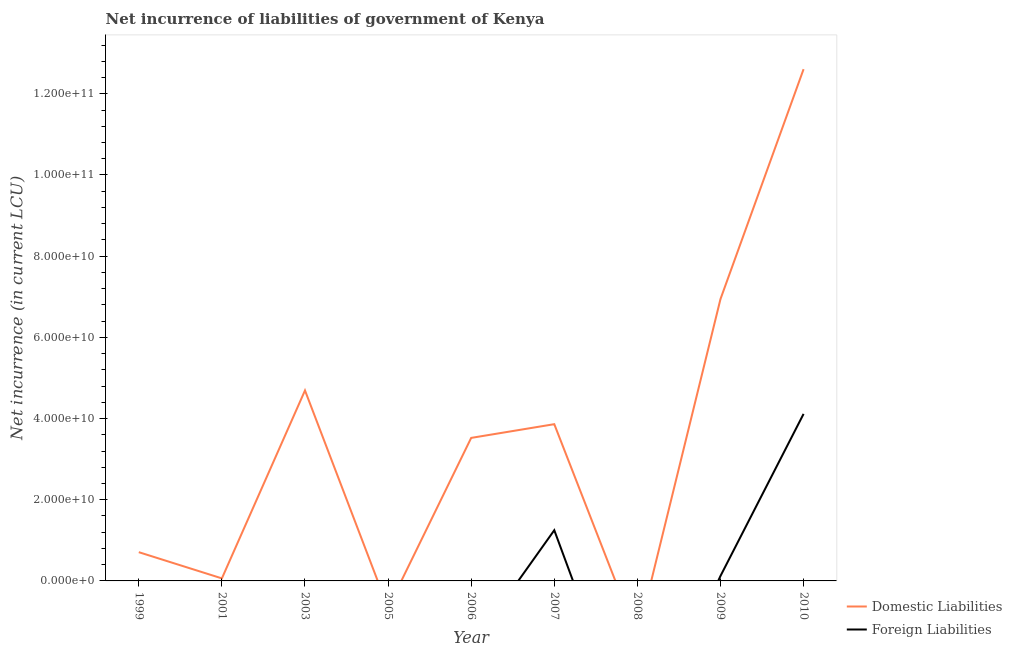What is the net incurrence of domestic liabilities in 1999?
Your response must be concise. 7.08e+09. Across all years, what is the maximum net incurrence of domestic liabilities?
Ensure brevity in your answer.  1.26e+11. Across all years, what is the minimum net incurrence of foreign liabilities?
Offer a very short reply. 0. What is the total net incurrence of domestic liabilities in the graph?
Your answer should be compact. 3.24e+11. What is the difference between the net incurrence of domestic liabilities in 1999 and that in 2001?
Provide a succinct answer. 6.46e+09. What is the average net incurrence of domestic liabilities per year?
Offer a terse response. 3.60e+1. In the year 2009, what is the difference between the net incurrence of foreign liabilities and net incurrence of domestic liabilities?
Provide a succinct answer. -6.82e+1. In how many years, is the net incurrence of foreign liabilities greater than 104000000000 LCU?
Provide a short and direct response. 0. What is the ratio of the net incurrence of domestic liabilities in 1999 to that in 2006?
Provide a succinct answer. 0.2. Is the net incurrence of domestic liabilities in 1999 less than that in 2003?
Your answer should be very brief. Yes. What is the difference between the highest and the second highest net incurrence of foreign liabilities?
Provide a succinct answer. 2.87e+1. What is the difference between the highest and the lowest net incurrence of foreign liabilities?
Ensure brevity in your answer.  4.11e+1. Is the sum of the net incurrence of foreign liabilities in 2007 and 2009 greater than the maximum net incurrence of domestic liabilities across all years?
Your response must be concise. No. Is the net incurrence of foreign liabilities strictly greater than the net incurrence of domestic liabilities over the years?
Provide a succinct answer. No. Is the net incurrence of domestic liabilities strictly less than the net incurrence of foreign liabilities over the years?
Your answer should be compact. No. How many lines are there?
Offer a very short reply. 2. How many years are there in the graph?
Give a very brief answer. 9. Are the values on the major ticks of Y-axis written in scientific E-notation?
Your answer should be compact. Yes. Does the graph contain grids?
Provide a short and direct response. No. Where does the legend appear in the graph?
Your answer should be compact. Bottom right. What is the title of the graph?
Provide a succinct answer. Net incurrence of liabilities of government of Kenya. What is the label or title of the X-axis?
Provide a succinct answer. Year. What is the label or title of the Y-axis?
Offer a terse response. Net incurrence (in current LCU). What is the Net incurrence (in current LCU) of Domestic Liabilities in 1999?
Keep it short and to the point. 7.08e+09. What is the Net incurrence (in current LCU) in Domestic Liabilities in 2001?
Provide a succinct answer. 6.24e+08. What is the Net incurrence (in current LCU) in Domestic Liabilities in 2003?
Provide a succinct answer. 4.69e+1. What is the Net incurrence (in current LCU) in Domestic Liabilities in 2006?
Offer a terse response. 3.52e+1. What is the Net incurrence (in current LCU) of Foreign Liabilities in 2006?
Ensure brevity in your answer.  0. What is the Net incurrence (in current LCU) of Domestic Liabilities in 2007?
Offer a very short reply. 3.86e+1. What is the Net incurrence (in current LCU) in Foreign Liabilities in 2007?
Provide a succinct answer. 1.25e+1. What is the Net incurrence (in current LCU) in Domestic Liabilities in 2008?
Offer a very short reply. 0. What is the Net incurrence (in current LCU) in Foreign Liabilities in 2008?
Give a very brief answer. 0. What is the Net incurrence (in current LCU) of Domestic Liabilities in 2009?
Provide a succinct answer. 6.94e+1. What is the Net incurrence (in current LCU) of Foreign Liabilities in 2009?
Your answer should be very brief. 1.22e+09. What is the Net incurrence (in current LCU) in Domestic Liabilities in 2010?
Give a very brief answer. 1.26e+11. What is the Net incurrence (in current LCU) of Foreign Liabilities in 2010?
Your answer should be very brief. 4.11e+1. Across all years, what is the maximum Net incurrence (in current LCU) in Domestic Liabilities?
Offer a very short reply. 1.26e+11. Across all years, what is the maximum Net incurrence (in current LCU) of Foreign Liabilities?
Your answer should be compact. 4.11e+1. Across all years, what is the minimum Net incurrence (in current LCU) of Domestic Liabilities?
Give a very brief answer. 0. Across all years, what is the minimum Net incurrence (in current LCU) in Foreign Liabilities?
Your answer should be compact. 0. What is the total Net incurrence (in current LCU) of Domestic Liabilities in the graph?
Your answer should be compact. 3.24e+11. What is the total Net incurrence (in current LCU) of Foreign Liabilities in the graph?
Offer a very short reply. 5.48e+1. What is the difference between the Net incurrence (in current LCU) of Domestic Liabilities in 1999 and that in 2001?
Ensure brevity in your answer.  6.46e+09. What is the difference between the Net incurrence (in current LCU) of Domestic Liabilities in 1999 and that in 2003?
Give a very brief answer. -3.98e+1. What is the difference between the Net incurrence (in current LCU) of Domestic Liabilities in 1999 and that in 2006?
Offer a terse response. -2.81e+1. What is the difference between the Net incurrence (in current LCU) in Domestic Liabilities in 1999 and that in 2007?
Ensure brevity in your answer.  -3.15e+1. What is the difference between the Net incurrence (in current LCU) in Domestic Liabilities in 1999 and that in 2009?
Your answer should be compact. -6.23e+1. What is the difference between the Net incurrence (in current LCU) in Domestic Liabilities in 1999 and that in 2010?
Provide a short and direct response. -1.19e+11. What is the difference between the Net incurrence (in current LCU) of Domestic Liabilities in 2001 and that in 2003?
Provide a succinct answer. -4.63e+1. What is the difference between the Net incurrence (in current LCU) of Domestic Liabilities in 2001 and that in 2006?
Offer a very short reply. -3.46e+1. What is the difference between the Net incurrence (in current LCU) in Domestic Liabilities in 2001 and that in 2007?
Provide a short and direct response. -3.80e+1. What is the difference between the Net incurrence (in current LCU) in Domestic Liabilities in 2001 and that in 2009?
Your response must be concise. -6.88e+1. What is the difference between the Net incurrence (in current LCU) in Domestic Liabilities in 2001 and that in 2010?
Offer a very short reply. -1.25e+11. What is the difference between the Net incurrence (in current LCU) of Domestic Liabilities in 2003 and that in 2006?
Provide a short and direct response. 1.17e+1. What is the difference between the Net incurrence (in current LCU) in Domestic Liabilities in 2003 and that in 2007?
Your answer should be compact. 8.31e+09. What is the difference between the Net incurrence (in current LCU) in Domestic Liabilities in 2003 and that in 2009?
Ensure brevity in your answer.  -2.25e+1. What is the difference between the Net incurrence (in current LCU) of Domestic Liabilities in 2003 and that in 2010?
Your answer should be very brief. -7.91e+1. What is the difference between the Net incurrence (in current LCU) of Domestic Liabilities in 2006 and that in 2007?
Your answer should be compact. -3.38e+09. What is the difference between the Net incurrence (in current LCU) in Domestic Liabilities in 2006 and that in 2009?
Ensure brevity in your answer.  -3.42e+1. What is the difference between the Net incurrence (in current LCU) of Domestic Liabilities in 2006 and that in 2010?
Your answer should be compact. -9.08e+1. What is the difference between the Net incurrence (in current LCU) of Domestic Liabilities in 2007 and that in 2009?
Ensure brevity in your answer.  -3.08e+1. What is the difference between the Net incurrence (in current LCU) of Foreign Liabilities in 2007 and that in 2009?
Your response must be concise. 1.13e+1. What is the difference between the Net incurrence (in current LCU) in Domestic Liabilities in 2007 and that in 2010?
Your answer should be compact. -8.74e+1. What is the difference between the Net incurrence (in current LCU) in Foreign Liabilities in 2007 and that in 2010?
Your answer should be very brief. -2.87e+1. What is the difference between the Net incurrence (in current LCU) in Domestic Liabilities in 2009 and that in 2010?
Your response must be concise. -5.66e+1. What is the difference between the Net incurrence (in current LCU) of Foreign Liabilities in 2009 and that in 2010?
Ensure brevity in your answer.  -3.99e+1. What is the difference between the Net incurrence (in current LCU) in Domestic Liabilities in 1999 and the Net incurrence (in current LCU) in Foreign Liabilities in 2007?
Your response must be concise. -5.41e+09. What is the difference between the Net incurrence (in current LCU) in Domestic Liabilities in 1999 and the Net incurrence (in current LCU) in Foreign Liabilities in 2009?
Make the answer very short. 5.87e+09. What is the difference between the Net incurrence (in current LCU) of Domestic Liabilities in 1999 and the Net incurrence (in current LCU) of Foreign Liabilities in 2010?
Offer a terse response. -3.41e+1. What is the difference between the Net incurrence (in current LCU) in Domestic Liabilities in 2001 and the Net incurrence (in current LCU) in Foreign Liabilities in 2007?
Give a very brief answer. -1.19e+1. What is the difference between the Net incurrence (in current LCU) of Domestic Liabilities in 2001 and the Net incurrence (in current LCU) of Foreign Liabilities in 2009?
Keep it short and to the point. -5.92e+08. What is the difference between the Net incurrence (in current LCU) of Domestic Liabilities in 2001 and the Net incurrence (in current LCU) of Foreign Liabilities in 2010?
Provide a succinct answer. -4.05e+1. What is the difference between the Net incurrence (in current LCU) of Domestic Liabilities in 2003 and the Net incurrence (in current LCU) of Foreign Liabilities in 2007?
Keep it short and to the point. 3.44e+1. What is the difference between the Net incurrence (in current LCU) in Domestic Liabilities in 2003 and the Net incurrence (in current LCU) in Foreign Liabilities in 2009?
Offer a very short reply. 4.57e+1. What is the difference between the Net incurrence (in current LCU) in Domestic Liabilities in 2003 and the Net incurrence (in current LCU) in Foreign Liabilities in 2010?
Your response must be concise. 5.78e+09. What is the difference between the Net incurrence (in current LCU) in Domestic Liabilities in 2006 and the Net incurrence (in current LCU) in Foreign Liabilities in 2007?
Your response must be concise. 2.27e+1. What is the difference between the Net incurrence (in current LCU) of Domestic Liabilities in 2006 and the Net incurrence (in current LCU) of Foreign Liabilities in 2009?
Your answer should be very brief. 3.40e+1. What is the difference between the Net incurrence (in current LCU) in Domestic Liabilities in 2006 and the Net incurrence (in current LCU) in Foreign Liabilities in 2010?
Make the answer very short. -5.91e+09. What is the difference between the Net incurrence (in current LCU) of Domestic Liabilities in 2007 and the Net incurrence (in current LCU) of Foreign Liabilities in 2009?
Your answer should be very brief. 3.74e+1. What is the difference between the Net incurrence (in current LCU) in Domestic Liabilities in 2007 and the Net incurrence (in current LCU) in Foreign Liabilities in 2010?
Offer a terse response. -2.53e+09. What is the difference between the Net incurrence (in current LCU) in Domestic Liabilities in 2009 and the Net incurrence (in current LCU) in Foreign Liabilities in 2010?
Your answer should be very brief. 2.83e+1. What is the average Net incurrence (in current LCU) in Domestic Liabilities per year?
Your answer should be very brief. 3.60e+1. What is the average Net incurrence (in current LCU) of Foreign Liabilities per year?
Keep it short and to the point. 6.09e+09. In the year 2007, what is the difference between the Net incurrence (in current LCU) in Domestic Liabilities and Net incurrence (in current LCU) in Foreign Liabilities?
Keep it short and to the point. 2.61e+1. In the year 2009, what is the difference between the Net incurrence (in current LCU) of Domestic Liabilities and Net incurrence (in current LCU) of Foreign Liabilities?
Your response must be concise. 6.82e+1. In the year 2010, what is the difference between the Net incurrence (in current LCU) in Domestic Liabilities and Net incurrence (in current LCU) in Foreign Liabilities?
Keep it short and to the point. 8.49e+1. What is the ratio of the Net incurrence (in current LCU) of Domestic Liabilities in 1999 to that in 2001?
Your response must be concise. 11.34. What is the ratio of the Net incurrence (in current LCU) in Domestic Liabilities in 1999 to that in 2003?
Your answer should be very brief. 0.15. What is the ratio of the Net incurrence (in current LCU) in Domestic Liabilities in 1999 to that in 2006?
Provide a succinct answer. 0.2. What is the ratio of the Net incurrence (in current LCU) in Domestic Liabilities in 1999 to that in 2007?
Make the answer very short. 0.18. What is the ratio of the Net incurrence (in current LCU) in Domestic Liabilities in 1999 to that in 2009?
Provide a short and direct response. 0.1. What is the ratio of the Net incurrence (in current LCU) of Domestic Liabilities in 1999 to that in 2010?
Offer a very short reply. 0.06. What is the ratio of the Net incurrence (in current LCU) in Domestic Liabilities in 2001 to that in 2003?
Give a very brief answer. 0.01. What is the ratio of the Net incurrence (in current LCU) of Domestic Liabilities in 2001 to that in 2006?
Ensure brevity in your answer.  0.02. What is the ratio of the Net incurrence (in current LCU) of Domestic Liabilities in 2001 to that in 2007?
Your answer should be compact. 0.02. What is the ratio of the Net incurrence (in current LCU) in Domestic Liabilities in 2001 to that in 2009?
Make the answer very short. 0.01. What is the ratio of the Net incurrence (in current LCU) in Domestic Liabilities in 2001 to that in 2010?
Make the answer very short. 0.01. What is the ratio of the Net incurrence (in current LCU) of Domestic Liabilities in 2003 to that in 2006?
Provide a succinct answer. 1.33. What is the ratio of the Net incurrence (in current LCU) in Domestic Liabilities in 2003 to that in 2007?
Make the answer very short. 1.22. What is the ratio of the Net incurrence (in current LCU) of Domestic Liabilities in 2003 to that in 2009?
Ensure brevity in your answer.  0.68. What is the ratio of the Net incurrence (in current LCU) of Domestic Liabilities in 2003 to that in 2010?
Your answer should be compact. 0.37. What is the ratio of the Net incurrence (in current LCU) of Domestic Liabilities in 2006 to that in 2007?
Provide a short and direct response. 0.91. What is the ratio of the Net incurrence (in current LCU) in Domestic Liabilities in 2006 to that in 2009?
Give a very brief answer. 0.51. What is the ratio of the Net incurrence (in current LCU) in Domestic Liabilities in 2006 to that in 2010?
Your response must be concise. 0.28. What is the ratio of the Net incurrence (in current LCU) in Domestic Liabilities in 2007 to that in 2009?
Ensure brevity in your answer.  0.56. What is the ratio of the Net incurrence (in current LCU) of Foreign Liabilities in 2007 to that in 2009?
Provide a short and direct response. 10.27. What is the ratio of the Net incurrence (in current LCU) in Domestic Liabilities in 2007 to that in 2010?
Your response must be concise. 0.31. What is the ratio of the Net incurrence (in current LCU) of Foreign Liabilities in 2007 to that in 2010?
Keep it short and to the point. 0.3. What is the ratio of the Net incurrence (in current LCU) in Domestic Liabilities in 2009 to that in 2010?
Offer a very short reply. 0.55. What is the ratio of the Net incurrence (in current LCU) in Foreign Liabilities in 2009 to that in 2010?
Offer a very short reply. 0.03. What is the difference between the highest and the second highest Net incurrence (in current LCU) in Domestic Liabilities?
Your answer should be compact. 5.66e+1. What is the difference between the highest and the second highest Net incurrence (in current LCU) in Foreign Liabilities?
Offer a very short reply. 2.87e+1. What is the difference between the highest and the lowest Net incurrence (in current LCU) of Domestic Liabilities?
Make the answer very short. 1.26e+11. What is the difference between the highest and the lowest Net incurrence (in current LCU) in Foreign Liabilities?
Your response must be concise. 4.11e+1. 